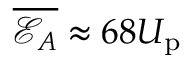<formula> <loc_0><loc_0><loc_500><loc_500>\overline { { \mathcal { E } _ { A } } } \approx 6 8 U _ { p }</formula> 